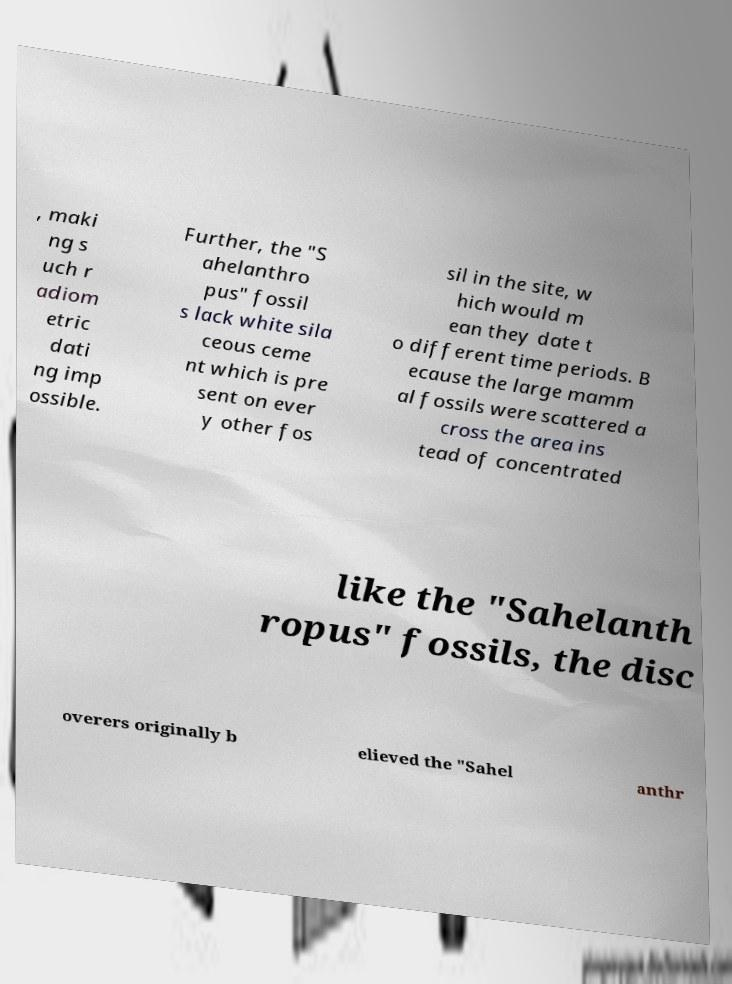What messages or text are displayed in this image? I need them in a readable, typed format. , maki ng s uch r adiom etric dati ng imp ossible. Further, the "S ahelanthro pus" fossil s lack white sila ceous ceme nt which is pre sent on ever y other fos sil in the site, w hich would m ean they date t o different time periods. B ecause the large mamm al fossils were scattered a cross the area ins tead of concentrated like the "Sahelanth ropus" fossils, the disc overers originally b elieved the "Sahel anthr 